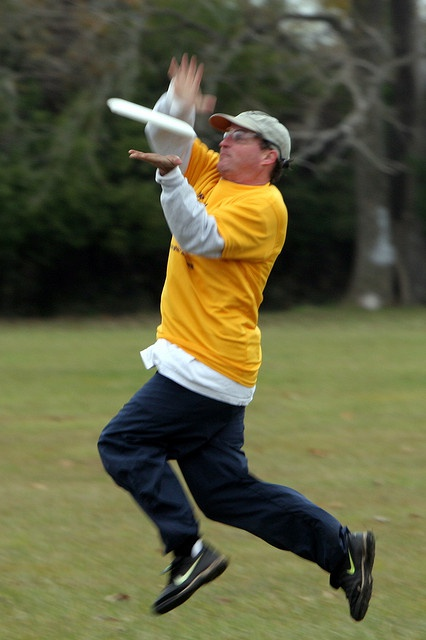Describe the objects in this image and their specific colors. I can see people in black, orange, olive, and darkgray tones, frisbee in black, white, darkgray, and lightgray tones, and frisbee in black, white, darkgray, and gray tones in this image. 